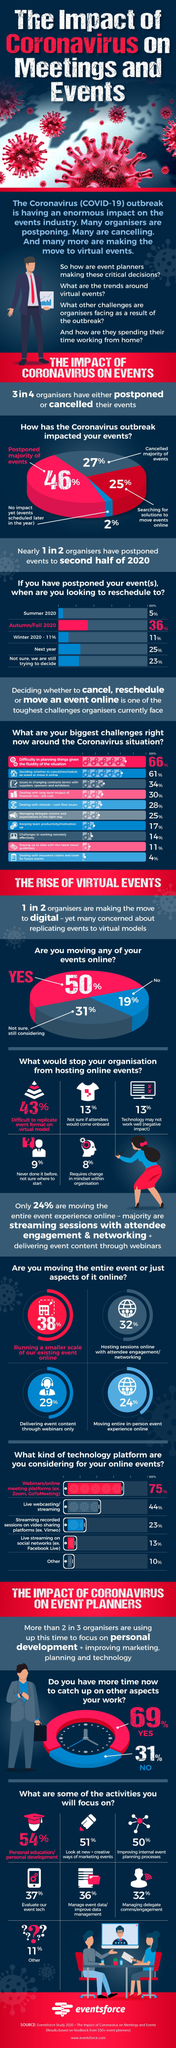What is listed fifth in the challenges faced by organisers?
Answer the question with a short phrase. Dealing with refunds + cash flow issues How many of the organisers plan on conducting a smaller scale of the event online 38% How many of the organisers deliver event content through webinars only? 29% What action has been taken by  46% of the organisers? postponed majority of events What percentage of organisers have difficulty replicating event in virtual model? 43% What percentage of organisers are not sure if attendees would come for online events? 13% What percentage of organisers have cancelled their events? 27% How many of the organisers are planning to conduct events online? 25% 